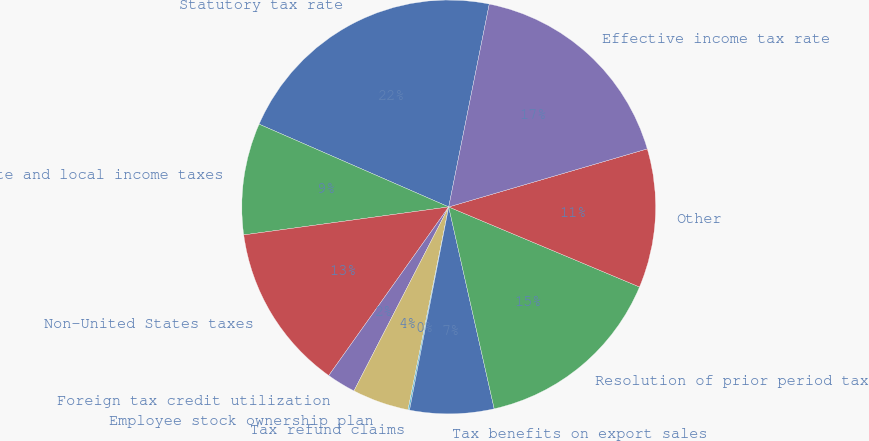<chart> <loc_0><loc_0><loc_500><loc_500><pie_chart><fcel>Statutory tax rate<fcel>State and local income taxes<fcel>Non-United States taxes<fcel>Foreign tax credit utilization<fcel>Employee stock ownership plan<fcel>Tax refund claims<fcel>Tax benefits on export sales<fcel>Resolution of prior period tax<fcel>Other<fcel>Effective income tax rate<nl><fcel>21.59%<fcel>8.71%<fcel>13.0%<fcel>2.27%<fcel>4.42%<fcel>0.12%<fcel>6.56%<fcel>15.15%<fcel>10.85%<fcel>17.33%<nl></chart> 